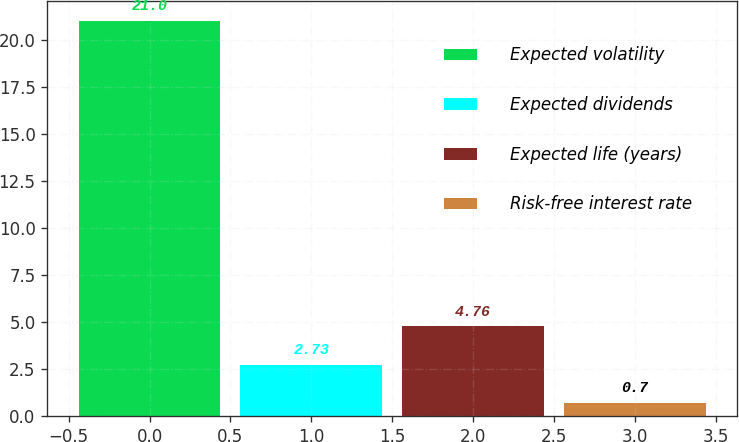Convert chart to OTSL. <chart><loc_0><loc_0><loc_500><loc_500><bar_chart><fcel>Expected volatility<fcel>Expected dividends<fcel>Expected life (years)<fcel>Risk-free interest rate<nl><fcel>21<fcel>2.73<fcel>4.76<fcel>0.7<nl></chart> 